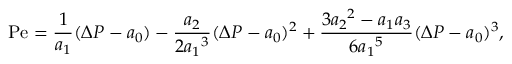<formula> <loc_0><loc_0><loc_500><loc_500>P e = \frac { 1 } { a _ { 1 } } ( \Delta P - a _ { 0 } ) - \frac { a _ { 2 } } { 2 { a _ { 1 } } ^ { 3 } } ( \Delta P - a _ { 0 } ) ^ { 2 } + \frac { 3 { a _ { 2 } } ^ { 2 } - a _ { 1 } a _ { 3 } } { 6 { a _ { 1 } } ^ { 5 } } ( \Delta P - a _ { 0 } ) ^ { 3 } ,</formula> 